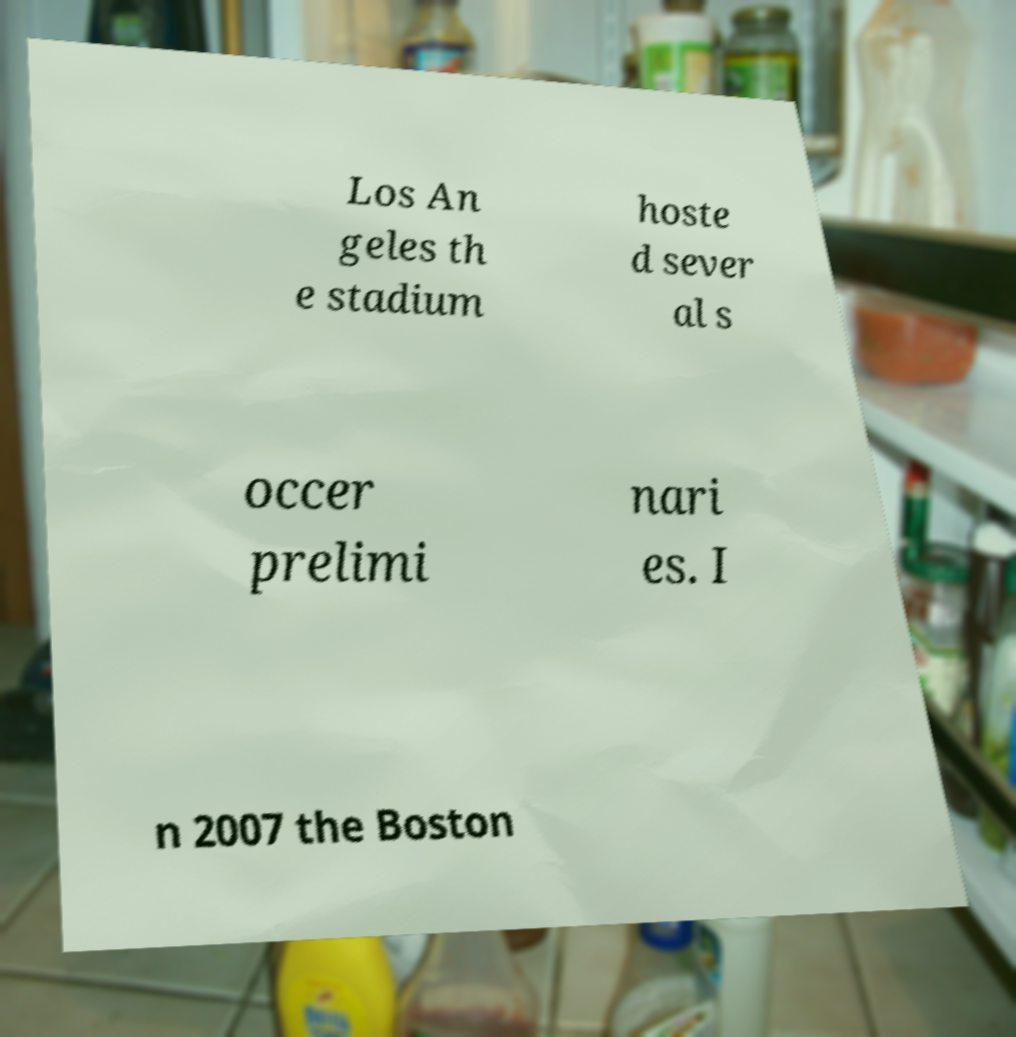Could you extract and type out the text from this image? Los An geles th e stadium hoste d sever al s occer prelimi nari es. I n 2007 the Boston 